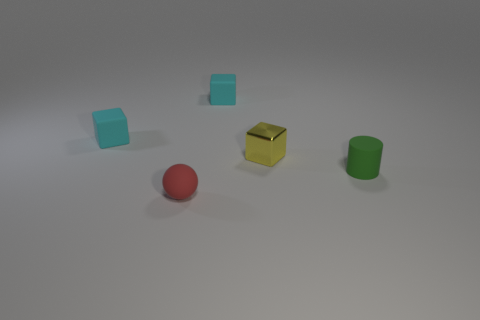There is a small thing that is in front of the yellow cube and to the left of the metal cube; what is its color?
Your response must be concise. Red. There is a yellow shiny block; is its size the same as the cyan matte object on the left side of the small red matte thing?
Your answer should be compact. Yes. Are there any other things that are the same shape as the small yellow shiny thing?
Your response must be concise. Yes. Do the green object and the red rubber sphere have the same size?
Ensure brevity in your answer.  Yes. What number of other things are the same size as the red thing?
Offer a terse response. 4. What number of objects are tiny objects in front of the tiny green cylinder or cyan blocks behind the green cylinder?
Make the answer very short. 3. There is a yellow metallic thing that is the same size as the red rubber sphere; what is its shape?
Give a very brief answer. Cube. What size is the ball that is the same material as the tiny green cylinder?
Your answer should be very brief. Small. Is the shape of the shiny object the same as the green rubber thing?
Provide a short and direct response. No. What color is the cylinder that is the same size as the yellow block?
Ensure brevity in your answer.  Green. 